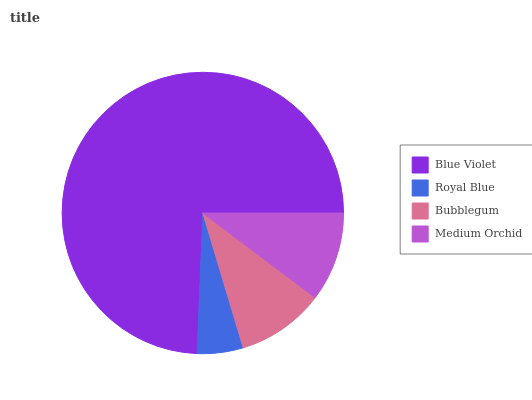Is Royal Blue the minimum?
Answer yes or no. Yes. Is Blue Violet the maximum?
Answer yes or no. Yes. Is Bubblegum the minimum?
Answer yes or no. No. Is Bubblegum the maximum?
Answer yes or no. No. Is Bubblegum greater than Royal Blue?
Answer yes or no. Yes. Is Royal Blue less than Bubblegum?
Answer yes or no. Yes. Is Royal Blue greater than Bubblegum?
Answer yes or no. No. Is Bubblegum less than Royal Blue?
Answer yes or no. No. Is Medium Orchid the high median?
Answer yes or no. Yes. Is Bubblegum the low median?
Answer yes or no. Yes. Is Bubblegum the high median?
Answer yes or no. No. Is Medium Orchid the low median?
Answer yes or no. No. 